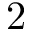Convert formula to latex. <formula><loc_0><loc_0><loc_500><loc_500>2</formula> 